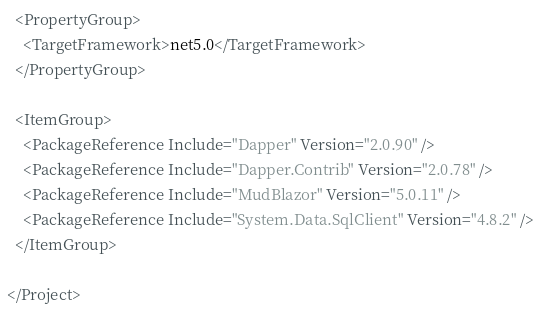Convert code to text. <code><loc_0><loc_0><loc_500><loc_500><_XML_>
  <PropertyGroup>
    <TargetFramework>net5.0</TargetFramework>
  </PropertyGroup>

  <ItemGroup>
    <PackageReference Include="Dapper" Version="2.0.90" />
    <PackageReference Include="Dapper.Contrib" Version="2.0.78" />
    <PackageReference Include="MudBlazor" Version="5.0.11" />
    <PackageReference Include="System.Data.SqlClient" Version="4.8.2" />
  </ItemGroup>

</Project>
</code> 